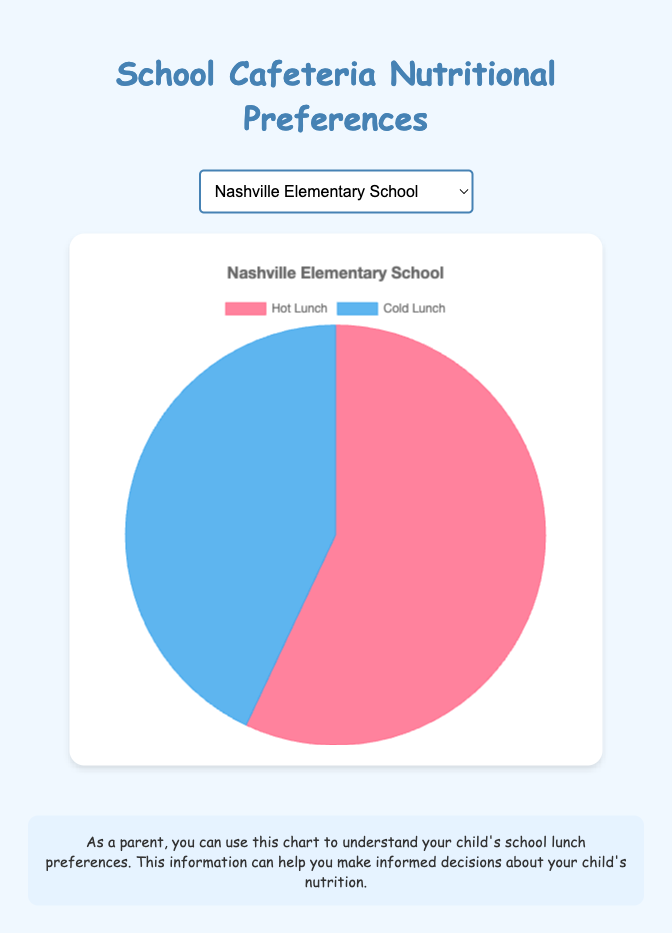Which school has a higher percentage of students preferring hot lunch, Nashville Elementary School or Memphis High School? Nashville Elementary School has 57% of students preferring hot lunch, while Memphis High School has 63%. Therefore, Memphis High School has a higher percentage.
Answer: Memphis High School What percentage of students prefer hot lunch at Clarksville High School? The percentage of students preferring hot lunch at Clarksville High School is shown as 55% on the pie chart.
Answer: 55% Which school has the smallest percentage difference between preferences for hot lunch and cold lunch? Calculating the differences: Nashville Elementary (57-43=14), Memphis High (63-37=26), Knoxville Middle (52-48=4), Chattanooga Elementary (59-41=18), Clarksville High (55-45=10), Murfreesboro Middle (60-40=20). Knoxville Middle School has the smallest difference.
Answer: Knoxville Middle School If we combine the data from Nashville Elementary and Chattanooga Elementary, what is the average percentage of students preferring hot lunch? Add the percentages of hot lunch preferences: Nashville Elementary (57%) + Chattanooga Elementary (59%) = 116. The average is 116 / 2 = 58%.
Answer: 58% Which has a greater number of schools where more than 55% of students prefer hot lunch, elementary or middle schools? Schools with more than 55%: Nashville Elementary (57%), Memphis High (63%), Chattanooga Elementary (59%), Murfreesboro Middle (60%). Among them, 2 are elementary (Nashville, Chattanooga), and 1 middle school (Murfreesboro).
Answer: Elementary Compare the percentage of students preferring cold lunch at Knoxville Middle School and Clarksville High School. Which school has more students preferring cold lunch? Knoxville Middle School has 48% preferring cold lunch, Clarksville High has 45%. Knoxville Middle School has more students preferring cold lunch.
Answer: Knoxville Middle School What is the total percentage of students preferring hot lunch across all schools? Adding all percentages of hot lunch preferences: 57 + 63 + 52 + 59 + 55 + 60 = 346. There are 6 schools, so 346% in total.
Answer: 346% What are the colors representing hot lunch and cold lunch in the pie chart? The pie chart uses red to represent hot lunch and blue to represent cold lunch.
Answer: Red, Blue 